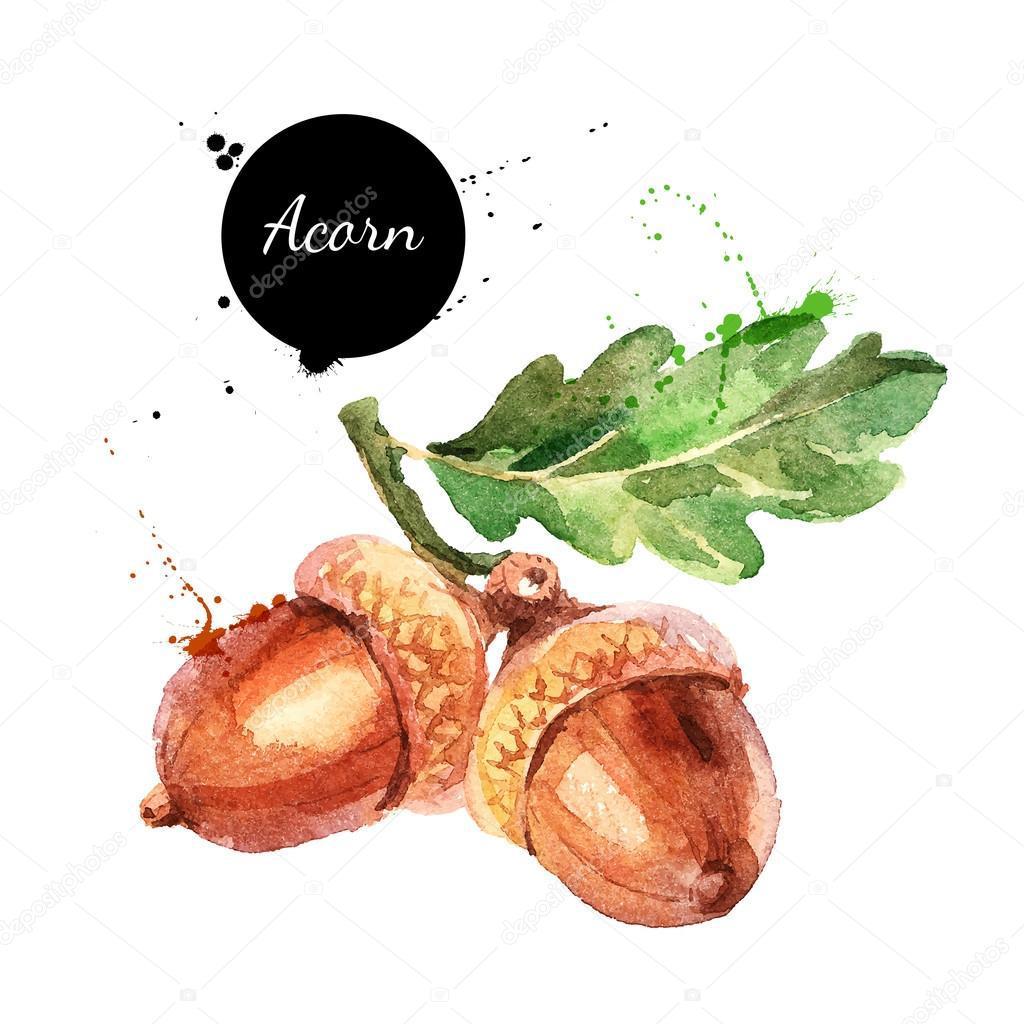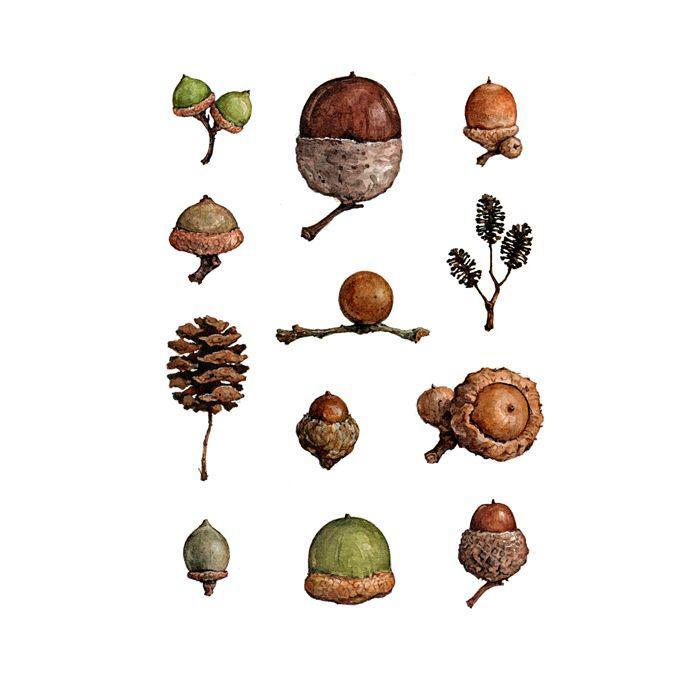The first image is the image on the left, the second image is the image on the right. Evaluate the accuracy of this statement regarding the images: "There are exactly two acorns in the left image.". Is it true? Answer yes or no. Yes. The first image is the image on the left, the second image is the image on the right. Assess this claim about the two images: "The left image includes two brown acorns, and at least one oak leaf on a stem above them.". Correct or not? Answer yes or no. Yes. 